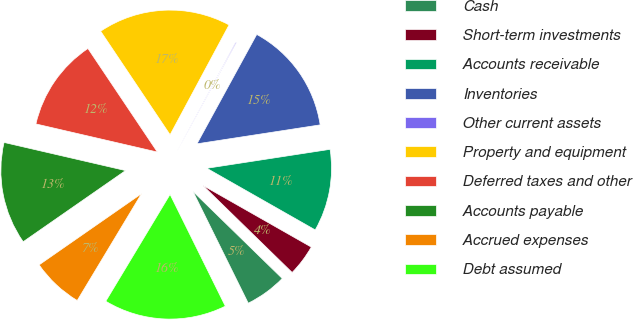<chart> <loc_0><loc_0><loc_500><loc_500><pie_chart><fcel>Cash<fcel>Short-term investments<fcel>Accounts receivable<fcel>Inventories<fcel>Other current assets<fcel>Property and equipment<fcel>Deferred taxes and other<fcel>Accounts payable<fcel>Accrued expenses<fcel>Debt assumed<nl><fcel>5.39%<fcel>4.07%<fcel>10.66%<fcel>14.61%<fcel>0.12%<fcel>17.24%<fcel>11.98%<fcel>13.29%<fcel>6.71%<fcel>15.93%<nl></chart> 